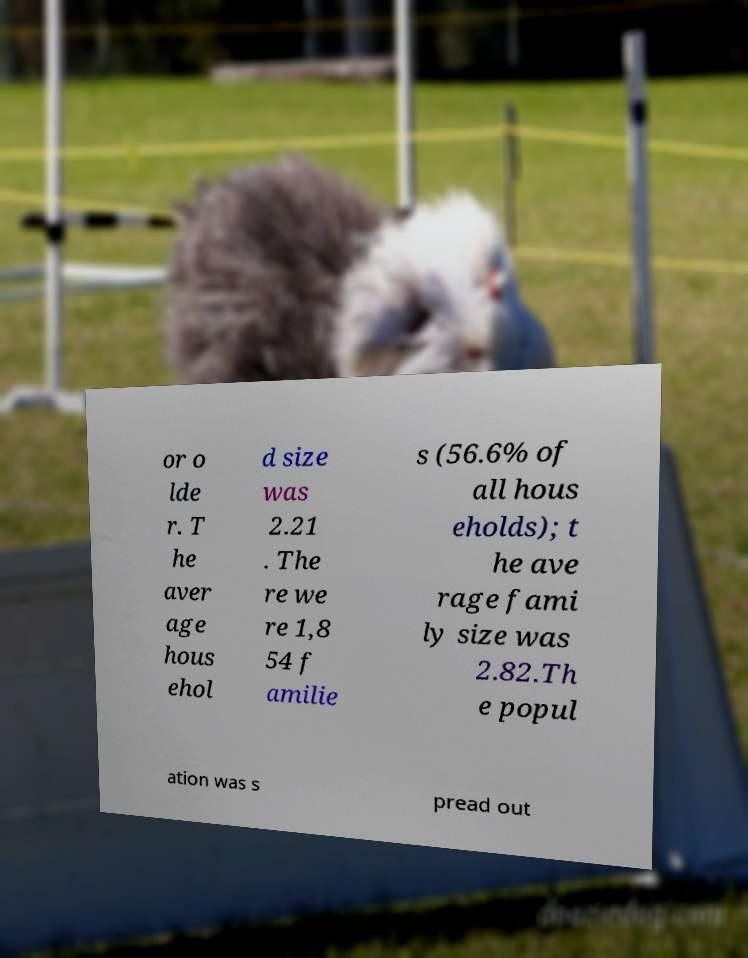Can you accurately transcribe the text from the provided image for me? or o lde r. T he aver age hous ehol d size was 2.21 . The re we re 1,8 54 f amilie s (56.6% of all hous eholds); t he ave rage fami ly size was 2.82.Th e popul ation was s pread out 